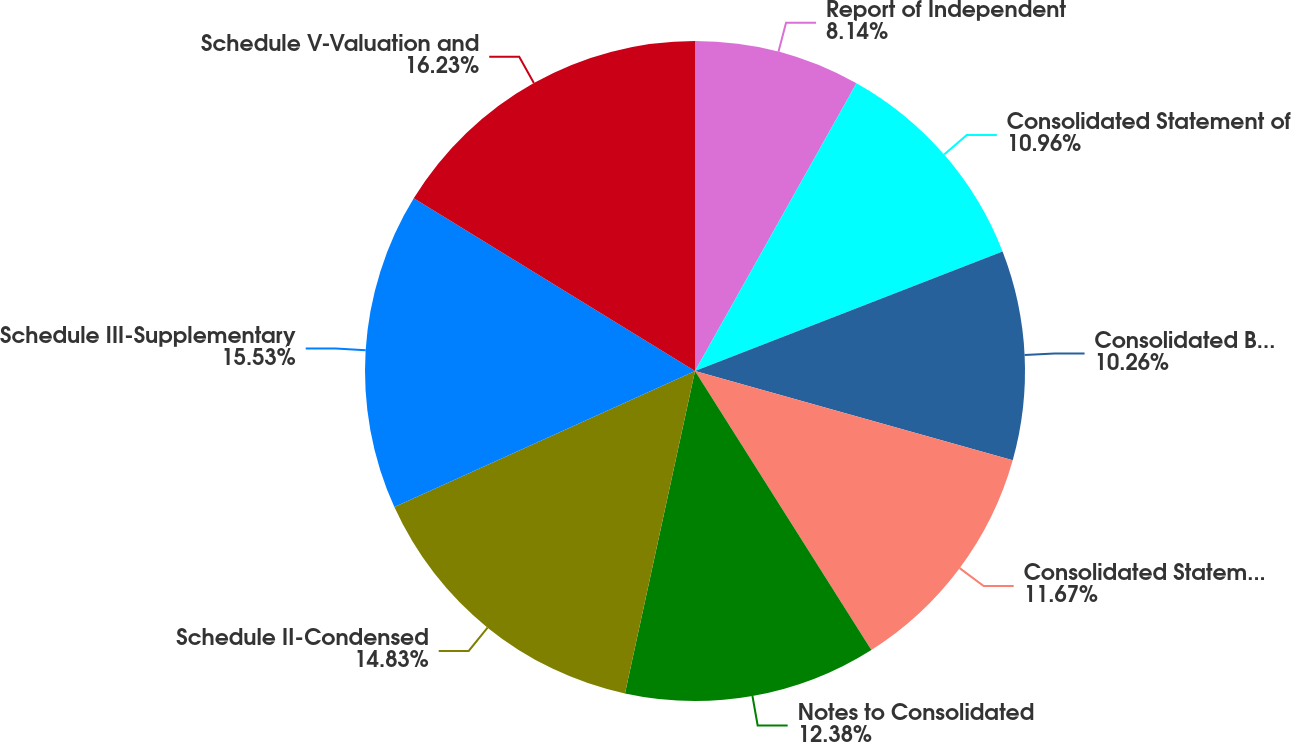Convert chart. <chart><loc_0><loc_0><loc_500><loc_500><pie_chart><fcel>Report of Independent<fcel>Consolidated Statement of<fcel>Consolidated Balance Sheet at<fcel>Consolidated Statement of Cash<fcel>Notes to Consolidated<fcel>Schedule II-Condensed<fcel>Schedule III-Supplementary<fcel>Schedule V-Valuation and<nl><fcel>8.14%<fcel>10.96%<fcel>10.26%<fcel>11.67%<fcel>12.38%<fcel>14.83%<fcel>15.53%<fcel>16.24%<nl></chart> 